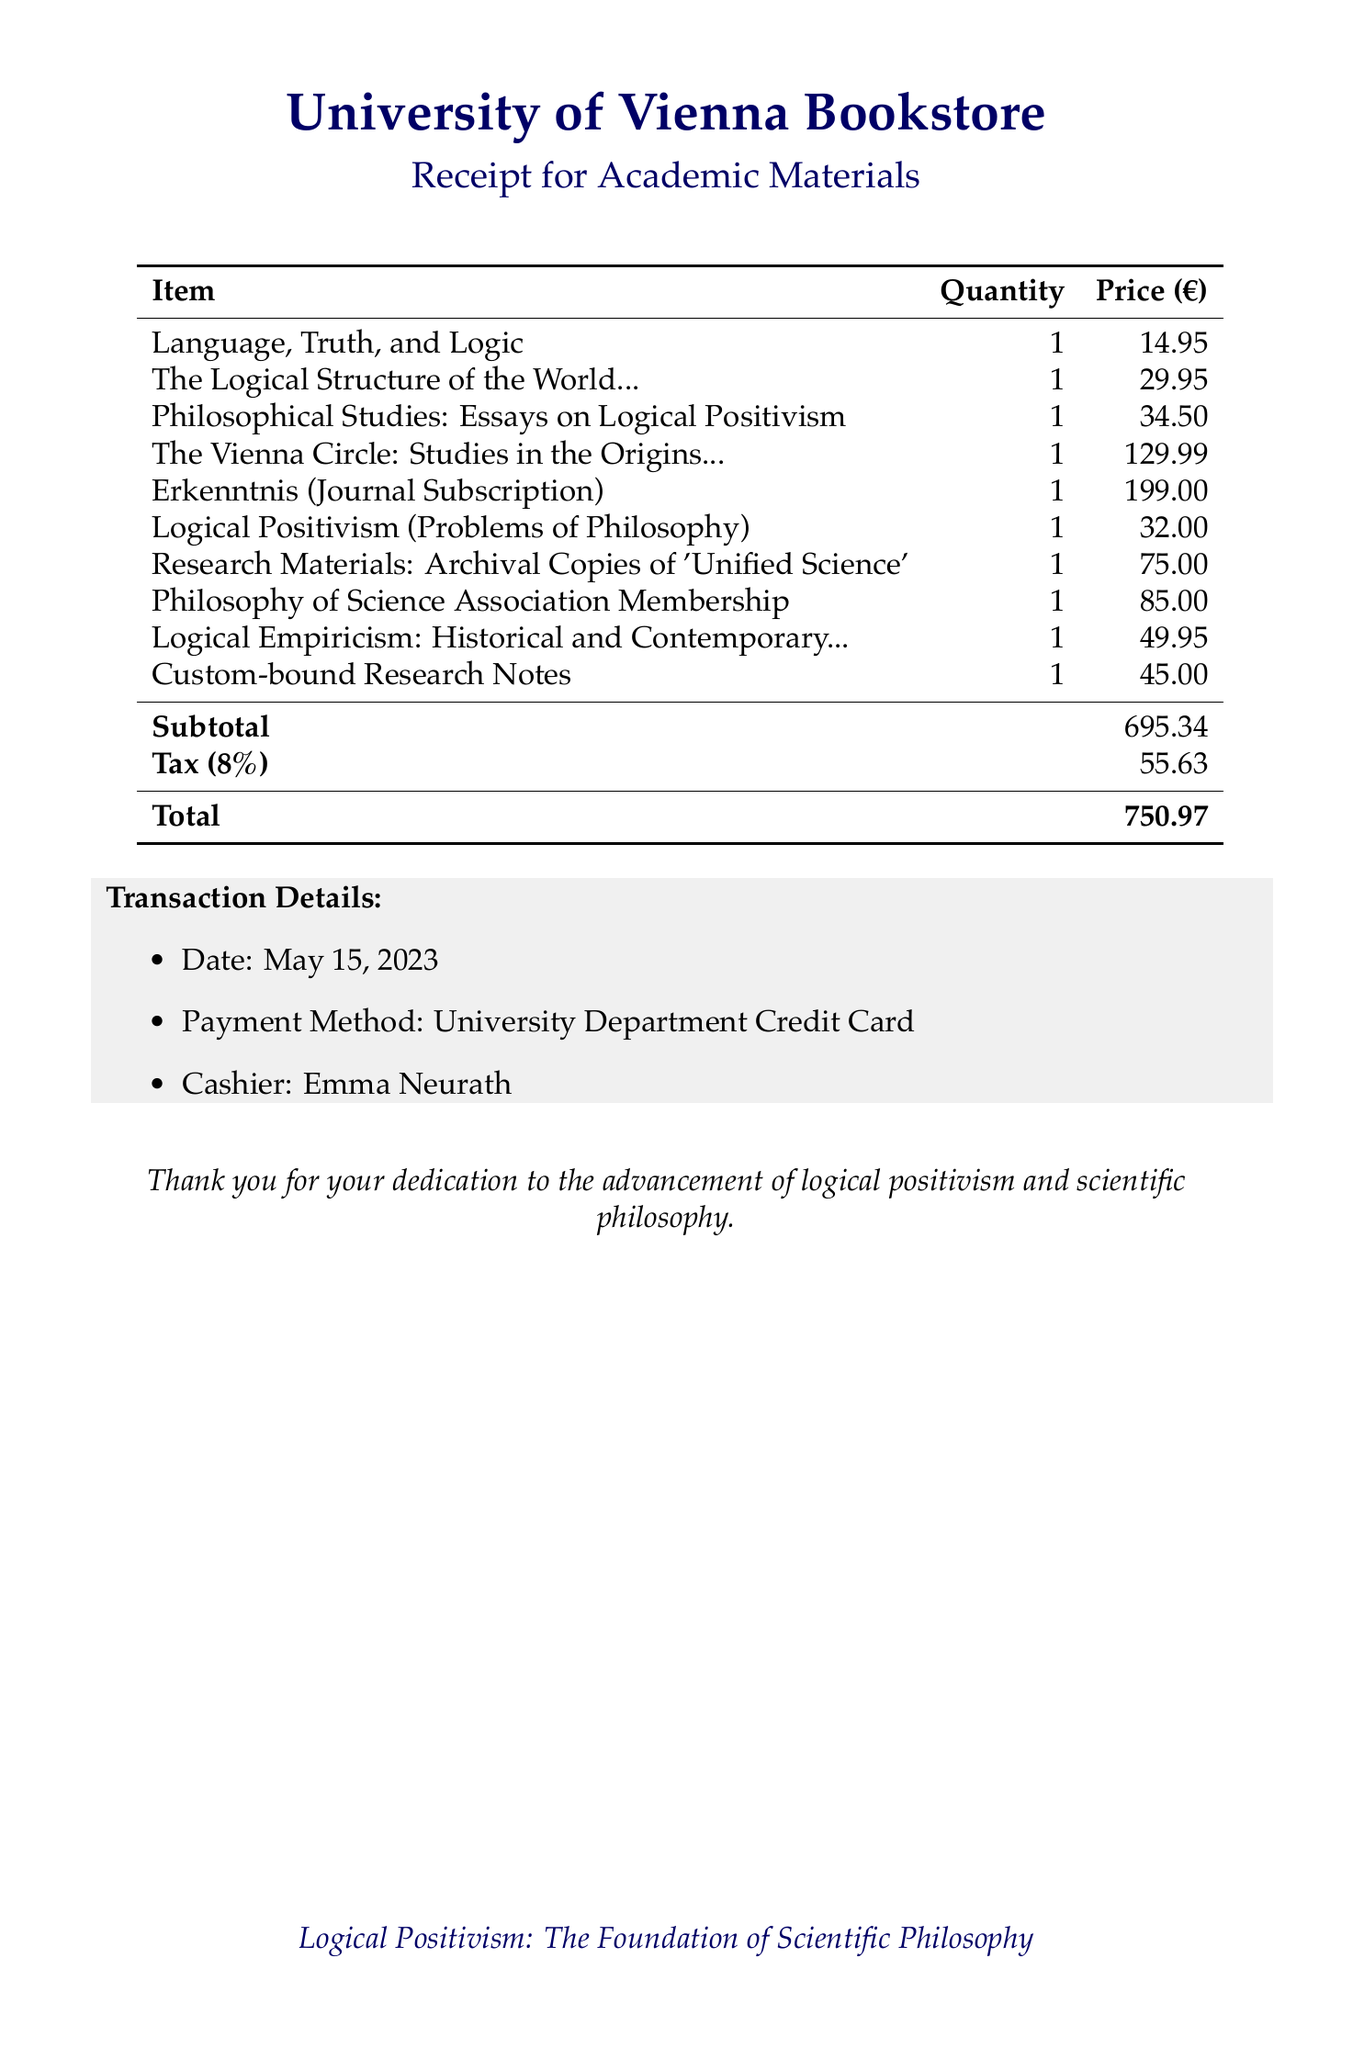What is the name of the bookstore? The name of the bookstore is explicitly mentioned in the document.
Answer: University of Vienna Bookstore Who is the author of "Language, Truth, and Logic"? The author of this book is clearly stated in the itemization of the document.
Answer: A.J. Ayer What is the total amount spent on the purchase? The total amount is displayed at the end of the itemized purchase list.
Answer: 750.97 How many items were purchased in total? The total number of items can be determined by counting the list of purchases in the document.
Answer: 10 What was the payment method used? The document specifies the payment method used for this transaction.
Answer: University Department Credit Card What is the tax rate applied to the purchase? The tax rate is explicitly stated in the subtotal and total section of the document.
Answer: 8% Which item is the most expensive? The most expensive item can be identified by comparing the prices listed in the document.
Answer: The Vienna Circle: Studies in the Origins, Development, and Influence of Logical Empiricism What is the transaction date? The date of the transaction is mentioned in the transaction details of the document.
Answer: May 15, 2023 What is the description of the "Erkenntnis" item? The description for this item is provided in the document and specifies what it entails.
Answer: Annual subscription to the journal of scientific philosophy 